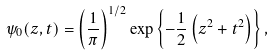<formula> <loc_0><loc_0><loc_500><loc_500>\psi _ { 0 } ( z , t ) = \left ( { \frac { 1 } { \pi } } \right ) ^ { 1 / 2 } \exp \left \{ - { \frac { 1 } { 2 } } \left ( z ^ { 2 } + t ^ { 2 } \right ) \right \} ,</formula> 